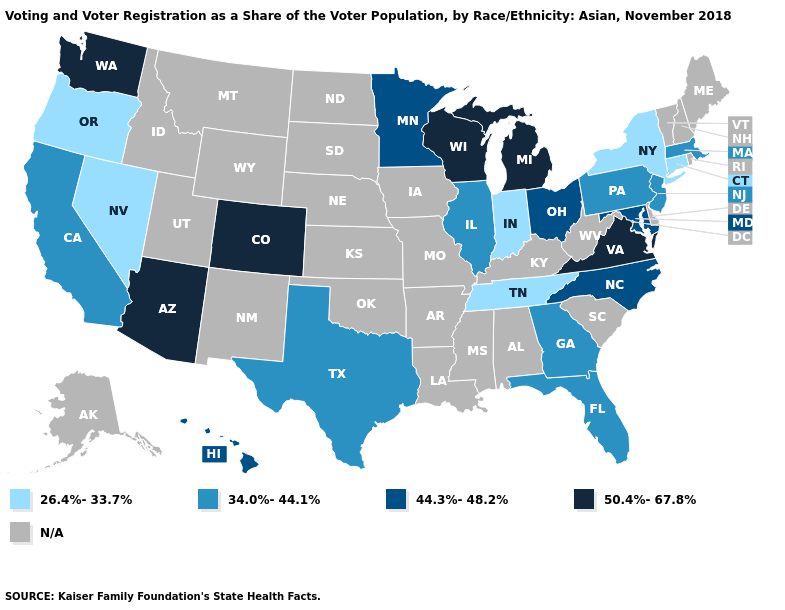Which states have the lowest value in the USA?
Answer briefly. Connecticut, Indiana, Nevada, New York, Oregon, Tennessee. What is the highest value in states that border South Dakota?
Write a very short answer. 44.3%-48.2%. What is the value of Maine?
Be succinct. N/A. What is the value of Colorado?
Concise answer only. 50.4%-67.8%. What is the value of Utah?
Answer briefly. N/A. What is the value of Iowa?
Write a very short answer. N/A. What is the highest value in the West ?
Concise answer only. 50.4%-67.8%. Name the states that have a value in the range 44.3%-48.2%?
Quick response, please. Hawaii, Maryland, Minnesota, North Carolina, Ohio. What is the value of Rhode Island?
Be succinct. N/A. Which states have the lowest value in the West?
Answer briefly. Nevada, Oregon. Among the states that border Michigan , which have the highest value?
Write a very short answer. Wisconsin. Which states have the lowest value in the South?
Give a very brief answer. Tennessee. Among the states that border North Carolina , does Georgia have the lowest value?
Keep it brief. No. 